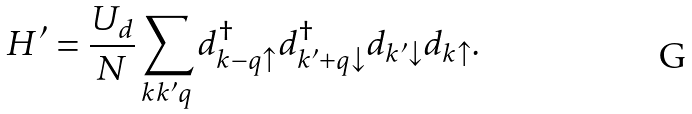Convert formula to latex. <formula><loc_0><loc_0><loc_500><loc_500>H ^ { \prime } = \frac { U _ { d } } { N } \sum _ { k k ^ { \prime } q } d _ { k - q \uparrow } ^ { \dag } d _ { k ^ { \prime } + q \downarrow } ^ { \dag } d _ { k ^ { \prime } \downarrow } d _ { k \uparrow } .</formula> 